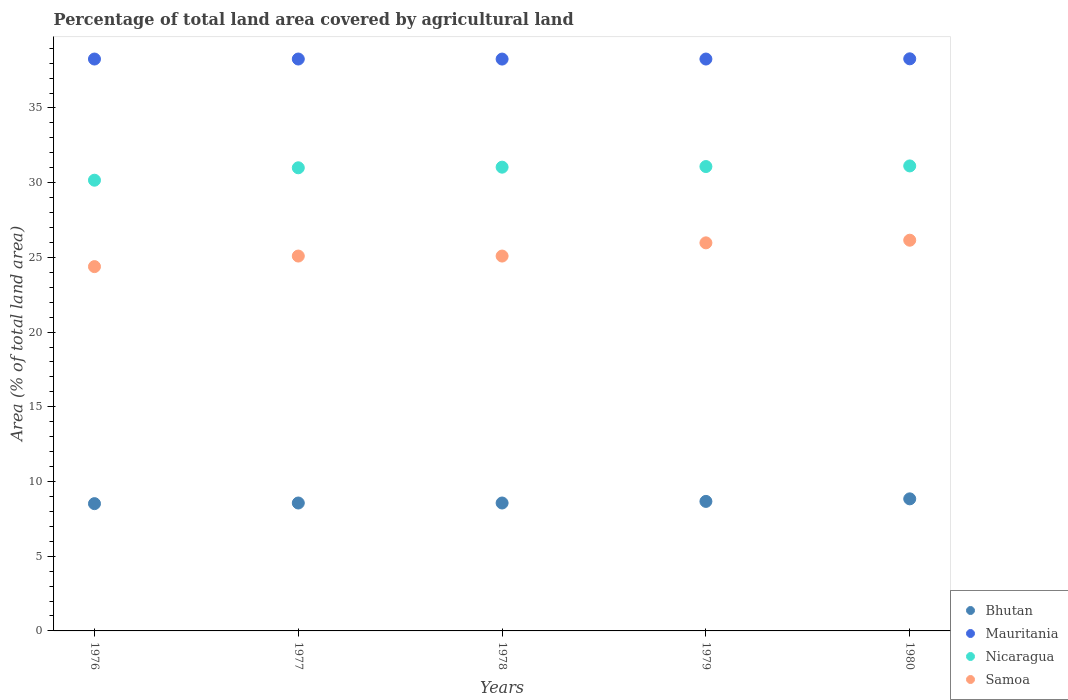How many different coloured dotlines are there?
Give a very brief answer. 4. What is the percentage of agricultural land in Nicaragua in 1977?
Offer a very short reply. 31. Across all years, what is the maximum percentage of agricultural land in Samoa?
Provide a short and direct response. 26.15. Across all years, what is the minimum percentage of agricultural land in Mauritania?
Make the answer very short. 38.27. In which year was the percentage of agricultural land in Nicaragua minimum?
Your answer should be compact. 1976. What is the total percentage of agricultural land in Mauritania in the graph?
Your response must be concise. 191.38. What is the difference between the percentage of agricultural land in Samoa in 1978 and that in 1980?
Your answer should be very brief. -1.06. What is the difference between the percentage of agricultural land in Mauritania in 1978 and the percentage of agricultural land in Nicaragua in 1976?
Your answer should be very brief. 8.11. What is the average percentage of agricultural land in Nicaragua per year?
Provide a succinct answer. 30.88. In the year 1977, what is the difference between the percentage of agricultural land in Samoa and percentage of agricultural land in Bhutan?
Your answer should be very brief. 16.53. What is the ratio of the percentage of agricultural land in Nicaragua in 1977 to that in 1979?
Provide a succinct answer. 1. Is the percentage of agricultural land in Samoa in 1978 less than that in 1979?
Your answer should be compact. Yes. What is the difference between the highest and the second highest percentage of agricultural land in Samoa?
Give a very brief answer. 0.18. What is the difference between the highest and the lowest percentage of agricultural land in Nicaragua?
Your answer should be compact. 0.96. Is it the case that in every year, the sum of the percentage of agricultural land in Mauritania and percentage of agricultural land in Samoa  is greater than the percentage of agricultural land in Bhutan?
Your answer should be compact. Yes. Does the percentage of agricultural land in Samoa monotonically increase over the years?
Provide a succinct answer. No. Is the percentage of agricultural land in Mauritania strictly less than the percentage of agricultural land in Samoa over the years?
Offer a terse response. No. Are the values on the major ticks of Y-axis written in scientific E-notation?
Your answer should be compact. No. Does the graph contain any zero values?
Provide a succinct answer. No. How many legend labels are there?
Your response must be concise. 4. What is the title of the graph?
Your answer should be very brief. Percentage of total land area covered by agricultural land. What is the label or title of the Y-axis?
Your answer should be compact. Area (% of total land area). What is the Area (% of total land area) of Bhutan in 1976?
Provide a succinct answer. 8.52. What is the Area (% of total land area) of Mauritania in 1976?
Your answer should be compact. 38.27. What is the Area (% of total land area) of Nicaragua in 1976?
Provide a succinct answer. 30.16. What is the Area (% of total land area) of Samoa in 1976?
Make the answer very short. 24.38. What is the Area (% of total land area) of Bhutan in 1977?
Offer a very short reply. 8.56. What is the Area (% of total land area) in Mauritania in 1977?
Keep it short and to the point. 38.27. What is the Area (% of total land area) of Nicaragua in 1977?
Provide a short and direct response. 31. What is the Area (% of total land area) of Samoa in 1977?
Keep it short and to the point. 25.09. What is the Area (% of total land area) of Bhutan in 1978?
Keep it short and to the point. 8.56. What is the Area (% of total land area) in Mauritania in 1978?
Your response must be concise. 38.27. What is the Area (% of total land area) of Nicaragua in 1978?
Give a very brief answer. 31.04. What is the Area (% of total land area) of Samoa in 1978?
Ensure brevity in your answer.  25.09. What is the Area (% of total land area) of Bhutan in 1979?
Make the answer very short. 8.67. What is the Area (% of total land area) in Mauritania in 1979?
Your answer should be compact. 38.27. What is the Area (% of total land area) in Nicaragua in 1979?
Offer a terse response. 31.08. What is the Area (% of total land area) in Samoa in 1979?
Offer a very short reply. 25.97. What is the Area (% of total land area) of Bhutan in 1980?
Offer a very short reply. 8.84. What is the Area (% of total land area) in Mauritania in 1980?
Make the answer very short. 38.29. What is the Area (% of total land area) in Nicaragua in 1980?
Offer a very short reply. 31.12. What is the Area (% of total land area) of Samoa in 1980?
Provide a short and direct response. 26.15. Across all years, what is the maximum Area (% of total land area) in Bhutan?
Offer a very short reply. 8.84. Across all years, what is the maximum Area (% of total land area) in Mauritania?
Provide a succinct answer. 38.29. Across all years, what is the maximum Area (% of total land area) in Nicaragua?
Your answer should be very brief. 31.12. Across all years, what is the maximum Area (% of total land area) in Samoa?
Offer a terse response. 26.15. Across all years, what is the minimum Area (% of total land area) in Bhutan?
Provide a succinct answer. 8.52. Across all years, what is the minimum Area (% of total land area) in Mauritania?
Keep it short and to the point. 38.27. Across all years, what is the minimum Area (% of total land area) of Nicaragua?
Provide a short and direct response. 30.16. Across all years, what is the minimum Area (% of total land area) of Samoa?
Offer a very short reply. 24.38. What is the total Area (% of total land area) of Bhutan in the graph?
Your answer should be compact. 43.15. What is the total Area (% of total land area) of Mauritania in the graph?
Ensure brevity in your answer.  191.38. What is the total Area (% of total land area) in Nicaragua in the graph?
Provide a succinct answer. 154.4. What is the total Area (% of total land area) of Samoa in the graph?
Your response must be concise. 126.68. What is the difference between the Area (% of total land area) in Bhutan in 1976 and that in 1977?
Offer a terse response. -0.04. What is the difference between the Area (% of total land area) in Mauritania in 1976 and that in 1977?
Make the answer very short. -0. What is the difference between the Area (% of total land area) of Nicaragua in 1976 and that in 1977?
Provide a short and direct response. -0.83. What is the difference between the Area (% of total land area) in Samoa in 1976 and that in 1977?
Provide a succinct answer. -0.71. What is the difference between the Area (% of total land area) of Bhutan in 1976 and that in 1978?
Your response must be concise. -0.04. What is the difference between the Area (% of total land area) in Mauritania in 1976 and that in 1978?
Your response must be concise. 0. What is the difference between the Area (% of total land area) in Nicaragua in 1976 and that in 1978?
Provide a succinct answer. -0.87. What is the difference between the Area (% of total land area) of Samoa in 1976 and that in 1978?
Your answer should be compact. -0.71. What is the difference between the Area (% of total land area) of Bhutan in 1976 and that in 1979?
Provide a succinct answer. -0.15. What is the difference between the Area (% of total land area) of Nicaragua in 1976 and that in 1979?
Provide a short and direct response. -0.91. What is the difference between the Area (% of total land area) in Samoa in 1976 and that in 1979?
Offer a very short reply. -1.59. What is the difference between the Area (% of total land area) in Bhutan in 1976 and that in 1980?
Provide a succinct answer. -0.32. What is the difference between the Area (% of total land area) in Mauritania in 1976 and that in 1980?
Provide a succinct answer. -0.01. What is the difference between the Area (% of total land area) in Nicaragua in 1976 and that in 1980?
Give a very brief answer. -0.96. What is the difference between the Area (% of total land area) in Samoa in 1976 and that in 1980?
Your response must be concise. -1.77. What is the difference between the Area (% of total land area) of Bhutan in 1977 and that in 1978?
Provide a short and direct response. 0. What is the difference between the Area (% of total land area) of Mauritania in 1977 and that in 1978?
Offer a very short reply. 0. What is the difference between the Area (% of total land area) of Nicaragua in 1977 and that in 1978?
Your answer should be very brief. -0.04. What is the difference between the Area (% of total land area) of Bhutan in 1977 and that in 1979?
Keep it short and to the point. -0.11. What is the difference between the Area (% of total land area) of Mauritania in 1977 and that in 1979?
Offer a very short reply. 0. What is the difference between the Area (% of total land area) in Nicaragua in 1977 and that in 1979?
Provide a succinct answer. -0.08. What is the difference between the Area (% of total land area) of Samoa in 1977 and that in 1979?
Give a very brief answer. -0.88. What is the difference between the Area (% of total land area) in Bhutan in 1977 and that in 1980?
Provide a short and direct response. -0.28. What is the difference between the Area (% of total land area) in Mauritania in 1977 and that in 1980?
Ensure brevity in your answer.  -0.01. What is the difference between the Area (% of total land area) in Nicaragua in 1977 and that in 1980?
Offer a terse response. -0.12. What is the difference between the Area (% of total land area) in Samoa in 1977 and that in 1980?
Keep it short and to the point. -1.06. What is the difference between the Area (% of total land area) of Bhutan in 1978 and that in 1979?
Your response must be concise. -0.11. What is the difference between the Area (% of total land area) in Mauritania in 1978 and that in 1979?
Provide a succinct answer. -0. What is the difference between the Area (% of total land area) in Nicaragua in 1978 and that in 1979?
Your response must be concise. -0.04. What is the difference between the Area (% of total land area) of Samoa in 1978 and that in 1979?
Your answer should be very brief. -0.88. What is the difference between the Area (% of total land area) in Bhutan in 1978 and that in 1980?
Keep it short and to the point. -0.28. What is the difference between the Area (% of total land area) in Mauritania in 1978 and that in 1980?
Make the answer very short. -0.02. What is the difference between the Area (% of total land area) of Nicaragua in 1978 and that in 1980?
Ensure brevity in your answer.  -0.08. What is the difference between the Area (% of total land area) in Samoa in 1978 and that in 1980?
Offer a terse response. -1.06. What is the difference between the Area (% of total land area) in Bhutan in 1979 and that in 1980?
Provide a succinct answer. -0.17. What is the difference between the Area (% of total land area) of Mauritania in 1979 and that in 1980?
Keep it short and to the point. -0.01. What is the difference between the Area (% of total land area) in Nicaragua in 1979 and that in 1980?
Provide a succinct answer. -0.04. What is the difference between the Area (% of total land area) in Samoa in 1979 and that in 1980?
Ensure brevity in your answer.  -0.18. What is the difference between the Area (% of total land area) in Bhutan in 1976 and the Area (% of total land area) in Mauritania in 1977?
Offer a terse response. -29.76. What is the difference between the Area (% of total land area) in Bhutan in 1976 and the Area (% of total land area) in Nicaragua in 1977?
Offer a terse response. -22.48. What is the difference between the Area (% of total land area) of Bhutan in 1976 and the Area (% of total land area) of Samoa in 1977?
Offer a very short reply. -16.57. What is the difference between the Area (% of total land area) in Mauritania in 1976 and the Area (% of total land area) in Nicaragua in 1977?
Keep it short and to the point. 7.28. What is the difference between the Area (% of total land area) of Mauritania in 1976 and the Area (% of total land area) of Samoa in 1977?
Your answer should be very brief. 13.19. What is the difference between the Area (% of total land area) in Nicaragua in 1976 and the Area (% of total land area) in Samoa in 1977?
Give a very brief answer. 5.08. What is the difference between the Area (% of total land area) in Bhutan in 1976 and the Area (% of total land area) in Mauritania in 1978?
Keep it short and to the point. -29.75. What is the difference between the Area (% of total land area) in Bhutan in 1976 and the Area (% of total land area) in Nicaragua in 1978?
Your answer should be very brief. -22.52. What is the difference between the Area (% of total land area) of Bhutan in 1976 and the Area (% of total land area) of Samoa in 1978?
Give a very brief answer. -16.57. What is the difference between the Area (% of total land area) in Mauritania in 1976 and the Area (% of total land area) in Nicaragua in 1978?
Your answer should be compact. 7.24. What is the difference between the Area (% of total land area) of Mauritania in 1976 and the Area (% of total land area) of Samoa in 1978?
Make the answer very short. 13.19. What is the difference between the Area (% of total land area) in Nicaragua in 1976 and the Area (% of total land area) in Samoa in 1978?
Offer a terse response. 5.08. What is the difference between the Area (% of total land area) of Bhutan in 1976 and the Area (% of total land area) of Mauritania in 1979?
Make the answer very short. -29.76. What is the difference between the Area (% of total land area) of Bhutan in 1976 and the Area (% of total land area) of Nicaragua in 1979?
Ensure brevity in your answer.  -22.56. What is the difference between the Area (% of total land area) in Bhutan in 1976 and the Area (% of total land area) in Samoa in 1979?
Your response must be concise. -17.45. What is the difference between the Area (% of total land area) in Mauritania in 1976 and the Area (% of total land area) in Nicaragua in 1979?
Make the answer very short. 7.2. What is the difference between the Area (% of total land area) of Mauritania in 1976 and the Area (% of total land area) of Samoa in 1979?
Offer a very short reply. 12.3. What is the difference between the Area (% of total land area) of Nicaragua in 1976 and the Area (% of total land area) of Samoa in 1979?
Offer a very short reply. 4.19. What is the difference between the Area (% of total land area) in Bhutan in 1976 and the Area (% of total land area) in Mauritania in 1980?
Provide a succinct answer. -29.77. What is the difference between the Area (% of total land area) in Bhutan in 1976 and the Area (% of total land area) in Nicaragua in 1980?
Make the answer very short. -22.6. What is the difference between the Area (% of total land area) of Bhutan in 1976 and the Area (% of total land area) of Samoa in 1980?
Provide a succinct answer. -17.63. What is the difference between the Area (% of total land area) of Mauritania in 1976 and the Area (% of total land area) of Nicaragua in 1980?
Provide a succinct answer. 7.15. What is the difference between the Area (% of total land area) of Mauritania in 1976 and the Area (% of total land area) of Samoa in 1980?
Keep it short and to the point. 12.13. What is the difference between the Area (% of total land area) of Nicaragua in 1976 and the Area (% of total land area) of Samoa in 1980?
Your answer should be very brief. 4.02. What is the difference between the Area (% of total land area) in Bhutan in 1977 and the Area (% of total land area) in Mauritania in 1978?
Give a very brief answer. -29.71. What is the difference between the Area (% of total land area) of Bhutan in 1977 and the Area (% of total land area) of Nicaragua in 1978?
Give a very brief answer. -22.48. What is the difference between the Area (% of total land area) in Bhutan in 1977 and the Area (% of total land area) in Samoa in 1978?
Ensure brevity in your answer.  -16.53. What is the difference between the Area (% of total land area) of Mauritania in 1977 and the Area (% of total land area) of Nicaragua in 1978?
Keep it short and to the point. 7.24. What is the difference between the Area (% of total land area) in Mauritania in 1977 and the Area (% of total land area) in Samoa in 1978?
Your answer should be very brief. 13.19. What is the difference between the Area (% of total land area) in Nicaragua in 1977 and the Area (% of total land area) in Samoa in 1978?
Your response must be concise. 5.91. What is the difference between the Area (% of total land area) in Bhutan in 1977 and the Area (% of total land area) in Mauritania in 1979?
Your response must be concise. -29.71. What is the difference between the Area (% of total land area) of Bhutan in 1977 and the Area (% of total land area) of Nicaragua in 1979?
Provide a short and direct response. -22.52. What is the difference between the Area (% of total land area) in Bhutan in 1977 and the Area (% of total land area) in Samoa in 1979?
Provide a succinct answer. -17.41. What is the difference between the Area (% of total land area) in Mauritania in 1977 and the Area (% of total land area) in Nicaragua in 1979?
Offer a very short reply. 7.2. What is the difference between the Area (% of total land area) in Mauritania in 1977 and the Area (% of total land area) in Samoa in 1979?
Provide a succinct answer. 12.3. What is the difference between the Area (% of total land area) in Nicaragua in 1977 and the Area (% of total land area) in Samoa in 1979?
Provide a succinct answer. 5.02. What is the difference between the Area (% of total land area) of Bhutan in 1977 and the Area (% of total land area) of Mauritania in 1980?
Offer a very short reply. -29.73. What is the difference between the Area (% of total land area) in Bhutan in 1977 and the Area (% of total land area) in Nicaragua in 1980?
Offer a terse response. -22.56. What is the difference between the Area (% of total land area) of Bhutan in 1977 and the Area (% of total land area) of Samoa in 1980?
Your answer should be compact. -17.59. What is the difference between the Area (% of total land area) of Mauritania in 1977 and the Area (% of total land area) of Nicaragua in 1980?
Offer a terse response. 7.15. What is the difference between the Area (% of total land area) in Mauritania in 1977 and the Area (% of total land area) in Samoa in 1980?
Keep it short and to the point. 12.13. What is the difference between the Area (% of total land area) in Nicaragua in 1977 and the Area (% of total land area) in Samoa in 1980?
Provide a short and direct response. 4.85. What is the difference between the Area (% of total land area) of Bhutan in 1978 and the Area (% of total land area) of Mauritania in 1979?
Provide a succinct answer. -29.71. What is the difference between the Area (% of total land area) of Bhutan in 1978 and the Area (% of total land area) of Nicaragua in 1979?
Your answer should be very brief. -22.52. What is the difference between the Area (% of total land area) of Bhutan in 1978 and the Area (% of total land area) of Samoa in 1979?
Provide a succinct answer. -17.41. What is the difference between the Area (% of total land area) in Mauritania in 1978 and the Area (% of total land area) in Nicaragua in 1979?
Provide a short and direct response. 7.19. What is the difference between the Area (% of total land area) in Mauritania in 1978 and the Area (% of total land area) in Samoa in 1979?
Offer a very short reply. 12.3. What is the difference between the Area (% of total land area) of Nicaragua in 1978 and the Area (% of total land area) of Samoa in 1979?
Your answer should be compact. 5.07. What is the difference between the Area (% of total land area) in Bhutan in 1978 and the Area (% of total land area) in Mauritania in 1980?
Keep it short and to the point. -29.73. What is the difference between the Area (% of total land area) of Bhutan in 1978 and the Area (% of total land area) of Nicaragua in 1980?
Keep it short and to the point. -22.56. What is the difference between the Area (% of total land area) in Bhutan in 1978 and the Area (% of total land area) in Samoa in 1980?
Provide a short and direct response. -17.59. What is the difference between the Area (% of total land area) in Mauritania in 1978 and the Area (% of total land area) in Nicaragua in 1980?
Keep it short and to the point. 7.15. What is the difference between the Area (% of total land area) of Mauritania in 1978 and the Area (% of total land area) of Samoa in 1980?
Keep it short and to the point. 12.12. What is the difference between the Area (% of total land area) of Nicaragua in 1978 and the Area (% of total land area) of Samoa in 1980?
Keep it short and to the point. 4.89. What is the difference between the Area (% of total land area) in Bhutan in 1979 and the Area (% of total land area) in Mauritania in 1980?
Keep it short and to the point. -29.62. What is the difference between the Area (% of total land area) in Bhutan in 1979 and the Area (% of total land area) in Nicaragua in 1980?
Provide a succinct answer. -22.45. What is the difference between the Area (% of total land area) in Bhutan in 1979 and the Area (% of total land area) in Samoa in 1980?
Your answer should be very brief. -17.48. What is the difference between the Area (% of total land area) in Mauritania in 1979 and the Area (% of total land area) in Nicaragua in 1980?
Give a very brief answer. 7.15. What is the difference between the Area (% of total land area) of Mauritania in 1979 and the Area (% of total land area) of Samoa in 1980?
Give a very brief answer. 12.13. What is the difference between the Area (% of total land area) of Nicaragua in 1979 and the Area (% of total land area) of Samoa in 1980?
Keep it short and to the point. 4.93. What is the average Area (% of total land area) in Bhutan per year?
Offer a very short reply. 8.63. What is the average Area (% of total land area) of Mauritania per year?
Offer a very short reply. 38.28. What is the average Area (% of total land area) in Nicaragua per year?
Your answer should be very brief. 30.88. What is the average Area (% of total land area) of Samoa per year?
Provide a succinct answer. 25.34. In the year 1976, what is the difference between the Area (% of total land area) of Bhutan and Area (% of total land area) of Mauritania?
Provide a succinct answer. -29.76. In the year 1976, what is the difference between the Area (% of total land area) of Bhutan and Area (% of total land area) of Nicaragua?
Give a very brief answer. -21.65. In the year 1976, what is the difference between the Area (% of total land area) in Bhutan and Area (% of total land area) in Samoa?
Offer a terse response. -15.86. In the year 1976, what is the difference between the Area (% of total land area) of Mauritania and Area (% of total land area) of Nicaragua?
Your response must be concise. 8.11. In the year 1976, what is the difference between the Area (% of total land area) of Mauritania and Area (% of total land area) of Samoa?
Your answer should be compact. 13.89. In the year 1976, what is the difference between the Area (% of total land area) of Nicaragua and Area (% of total land area) of Samoa?
Provide a succinct answer. 5.78. In the year 1977, what is the difference between the Area (% of total land area) of Bhutan and Area (% of total land area) of Mauritania?
Give a very brief answer. -29.71. In the year 1977, what is the difference between the Area (% of total land area) of Bhutan and Area (% of total land area) of Nicaragua?
Ensure brevity in your answer.  -22.43. In the year 1977, what is the difference between the Area (% of total land area) of Bhutan and Area (% of total land area) of Samoa?
Provide a succinct answer. -16.53. In the year 1977, what is the difference between the Area (% of total land area) of Mauritania and Area (% of total land area) of Nicaragua?
Your answer should be compact. 7.28. In the year 1977, what is the difference between the Area (% of total land area) of Mauritania and Area (% of total land area) of Samoa?
Ensure brevity in your answer.  13.19. In the year 1977, what is the difference between the Area (% of total land area) in Nicaragua and Area (% of total land area) in Samoa?
Make the answer very short. 5.91. In the year 1978, what is the difference between the Area (% of total land area) in Bhutan and Area (% of total land area) in Mauritania?
Provide a succinct answer. -29.71. In the year 1978, what is the difference between the Area (% of total land area) in Bhutan and Area (% of total land area) in Nicaragua?
Ensure brevity in your answer.  -22.48. In the year 1978, what is the difference between the Area (% of total land area) of Bhutan and Area (% of total land area) of Samoa?
Make the answer very short. -16.53. In the year 1978, what is the difference between the Area (% of total land area) in Mauritania and Area (% of total land area) in Nicaragua?
Ensure brevity in your answer.  7.23. In the year 1978, what is the difference between the Area (% of total land area) in Mauritania and Area (% of total land area) in Samoa?
Offer a terse response. 13.18. In the year 1978, what is the difference between the Area (% of total land area) of Nicaragua and Area (% of total land area) of Samoa?
Offer a terse response. 5.95. In the year 1979, what is the difference between the Area (% of total land area) of Bhutan and Area (% of total land area) of Mauritania?
Keep it short and to the point. -29.61. In the year 1979, what is the difference between the Area (% of total land area) of Bhutan and Area (% of total land area) of Nicaragua?
Ensure brevity in your answer.  -22.41. In the year 1979, what is the difference between the Area (% of total land area) of Bhutan and Area (% of total land area) of Samoa?
Your answer should be very brief. -17.3. In the year 1979, what is the difference between the Area (% of total land area) in Mauritania and Area (% of total land area) in Nicaragua?
Your answer should be very brief. 7.2. In the year 1979, what is the difference between the Area (% of total land area) in Mauritania and Area (% of total land area) in Samoa?
Provide a succinct answer. 12.3. In the year 1979, what is the difference between the Area (% of total land area) of Nicaragua and Area (% of total land area) of Samoa?
Provide a succinct answer. 5.11. In the year 1980, what is the difference between the Area (% of total land area) of Bhutan and Area (% of total land area) of Mauritania?
Provide a short and direct response. -29.45. In the year 1980, what is the difference between the Area (% of total land area) in Bhutan and Area (% of total land area) in Nicaragua?
Your answer should be compact. -22.28. In the year 1980, what is the difference between the Area (% of total land area) in Bhutan and Area (% of total land area) in Samoa?
Provide a succinct answer. -17.31. In the year 1980, what is the difference between the Area (% of total land area) in Mauritania and Area (% of total land area) in Nicaragua?
Keep it short and to the point. 7.17. In the year 1980, what is the difference between the Area (% of total land area) of Mauritania and Area (% of total land area) of Samoa?
Keep it short and to the point. 12.14. In the year 1980, what is the difference between the Area (% of total land area) in Nicaragua and Area (% of total land area) in Samoa?
Offer a very short reply. 4.97. What is the ratio of the Area (% of total land area) of Bhutan in 1976 to that in 1977?
Provide a succinct answer. 0.99. What is the ratio of the Area (% of total land area) in Nicaragua in 1976 to that in 1977?
Your answer should be very brief. 0.97. What is the ratio of the Area (% of total land area) in Samoa in 1976 to that in 1977?
Your answer should be compact. 0.97. What is the ratio of the Area (% of total land area) of Nicaragua in 1976 to that in 1978?
Offer a very short reply. 0.97. What is the ratio of the Area (% of total land area) in Samoa in 1976 to that in 1978?
Your answer should be compact. 0.97. What is the ratio of the Area (% of total land area) in Bhutan in 1976 to that in 1979?
Your response must be concise. 0.98. What is the ratio of the Area (% of total land area) in Nicaragua in 1976 to that in 1979?
Ensure brevity in your answer.  0.97. What is the ratio of the Area (% of total land area) in Samoa in 1976 to that in 1979?
Your answer should be compact. 0.94. What is the ratio of the Area (% of total land area) of Bhutan in 1976 to that in 1980?
Your answer should be compact. 0.96. What is the ratio of the Area (% of total land area) of Mauritania in 1976 to that in 1980?
Offer a terse response. 1. What is the ratio of the Area (% of total land area) in Nicaragua in 1976 to that in 1980?
Keep it short and to the point. 0.97. What is the ratio of the Area (% of total land area) in Samoa in 1976 to that in 1980?
Ensure brevity in your answer.  0.93. What is the ratio of the Area (% of total land area) in Nicaragua in 1977 to that in 1978?
Make the answer very short. 1. What is the ratio of the Area (% of total land area) in Samoa in 1977 to that in 1978?
Offer a very short reply. 1. What is the ratio of the Area (% of total land area) in Mauritania in 1977 to that in 1979?
Ensure brevity in your answer.  1. What is the ratio of the Area (% of total land area) of Nicaragua in 1977 to that in 1979?
Keep it short and to the point. 1. What is the ratio of the Area (% of total land area) of Bhutan in 1977 to that in 1980?
Provide a short and direct response. 0.97. What is the ratio of the Area (% of total land area) in Mauritania in 1977 to that in 1980?
Provide a succinct answer. 1. What is the ratio of the Area (% of total land area) in Nicaragua in 1977 to that in 1980?
Ensure brevity in your answer.  1. What is the ratio of the Area (% of total land area) in Samoa in 1977 to that in 1980?
Your answer should be very brief. 0.96. What is the ratio of the Area (% of total land area) of Bhutan in 1978 to that in 1980?
Your response must be concise. 0.97. What is the ratio of the Area (% of total land area) of Nicaragua in 1978 to that in 1980?
Give a very brief answer. 1. What is the ratio of the Area (% of total land area) of Samoa in 1978 to that in 1980?
Ensure brevity in your answer.  0.96. What is the ratio of the Area (% of total land area) of Bhutan in 1979 to that in 1980?
Give a very brief answer. 0.98. What is the ratio of the Area (% of total land area) in Mauritania in 1979 to that in 1980?
Your answer should be very brief. 1. What is the ratio of the Area (% of total land area) in Nicaragua in 1979 to that in 1980?
Ensure brevity in your answer.  1. What is the difference between the highest and the second highest Area (% of total land area) of Bhutan?
Your answer should be compact. 0.17. What is the difference between the highest and the second highest Area (% of total land area) of Mauritania?
Ensure brevity in your answer.  0.01. What is the difference between the highest and the second highest Area (% of total land area) in Nicaragua?
Your answer should be compact. 0.04. What is the difference between the highest and the second highest Area (% of total land area) in Samoa?
Make the answer very short. 0.18. What is the difference between the highest and the lowest Area (% of total land area) of Bhutan?
Offer a very short reply. 0.32. What is the difference between the highest and the lowest Area (% of total land area) in Mauritania?
Provide a short and direct response. 0.02. What is the difference between the highest and the lowest Area (% of total land area) in Nicaragua?
Your response must be concise. 0.96. What is the difference between the highest and the lowest Area (% of total land area) of Samoa?
Your answer should be compact. 1.77. 